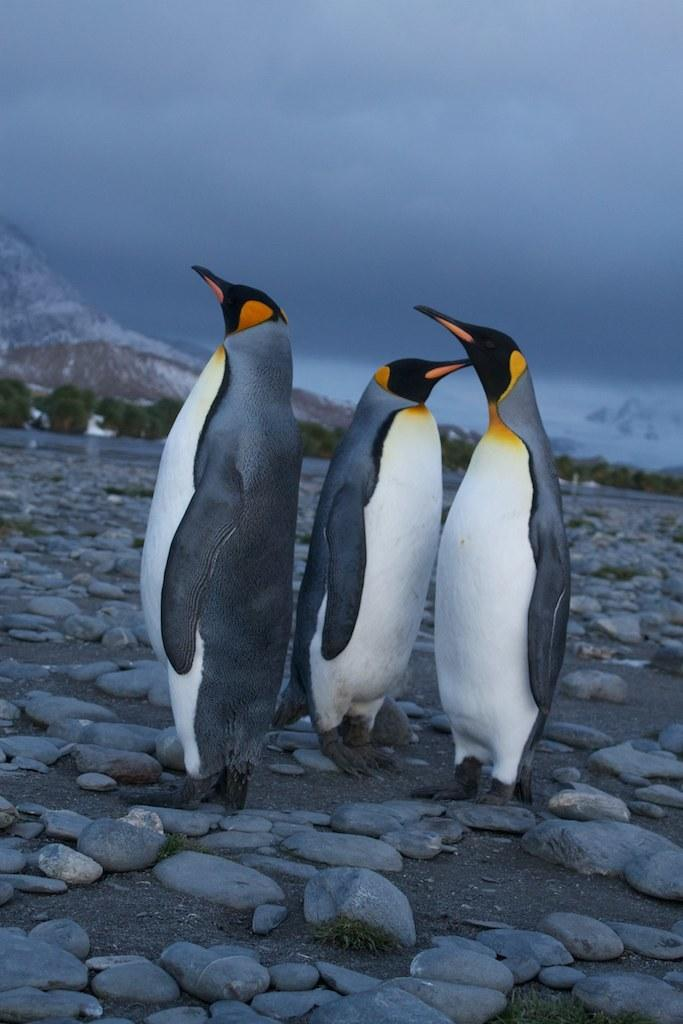How many penguins are in the image? There are three penguins in the image. Where are the penguins located? The penguins are on a beach. What can be seen in the background of the image? There is water, trees, mountains, and the sky visible in the background of the image. What is the setting of the image? The image is taken near the beach. What type of rings are the penguins wearing on their flippers in the image? There are no rings visible on the penguins' flippers in the image. What type of wool is used to make the penguins' coats in the image? The penguins in the image are real animals and do not have coats made of wool. 